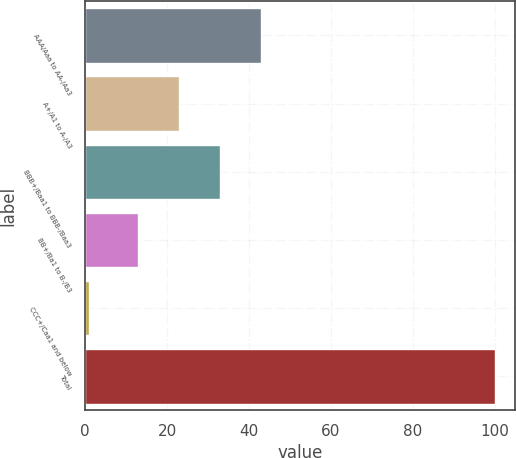Convert chart. <chart><loc_0><loc_0><loc_500><loc_500><bar_chart><fcel>AAA/Aaa to AA-/Aa3<fcel>A+/A1 to A-/A3<fcel>BBB+/Baa1 to BBB-/Baa3<fcel>BB+/Ba1 to B-/B3<fcel>CCC+/Caa1 and below<fcel>Total<nl><fcel>42.8<fcel>23<fcel>32.9<fcel>13<fcel>1<fcel>100<nl></chart> 